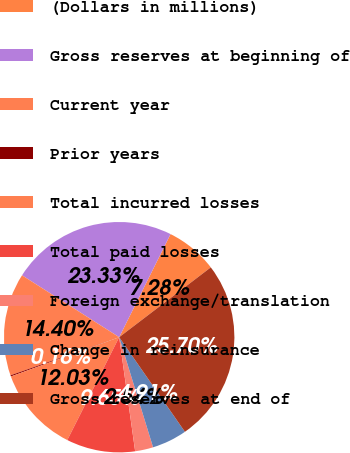<chart> <loc_0><loc_0><loc_500><loc_500><pie_chart><fcel>(Dollars in millions)<fcel>Gross reserves at beginning of<fcel>Current year<fcel>Prior years<fcel>Total incurred losses<fcel>Total paid losses<fcel>Foreign exchange/translation<fcel>Change in reinsurance<fcel>Gross reserves at end of<nl><fcel>7.28%<fcel>23.33%<fcel>14.4%<fcel>0.16%<fcel>12.03%<fcel>9.65%<fcel>2.54%<fcel>4.91%<fcel>25.7%<nl></chart> 